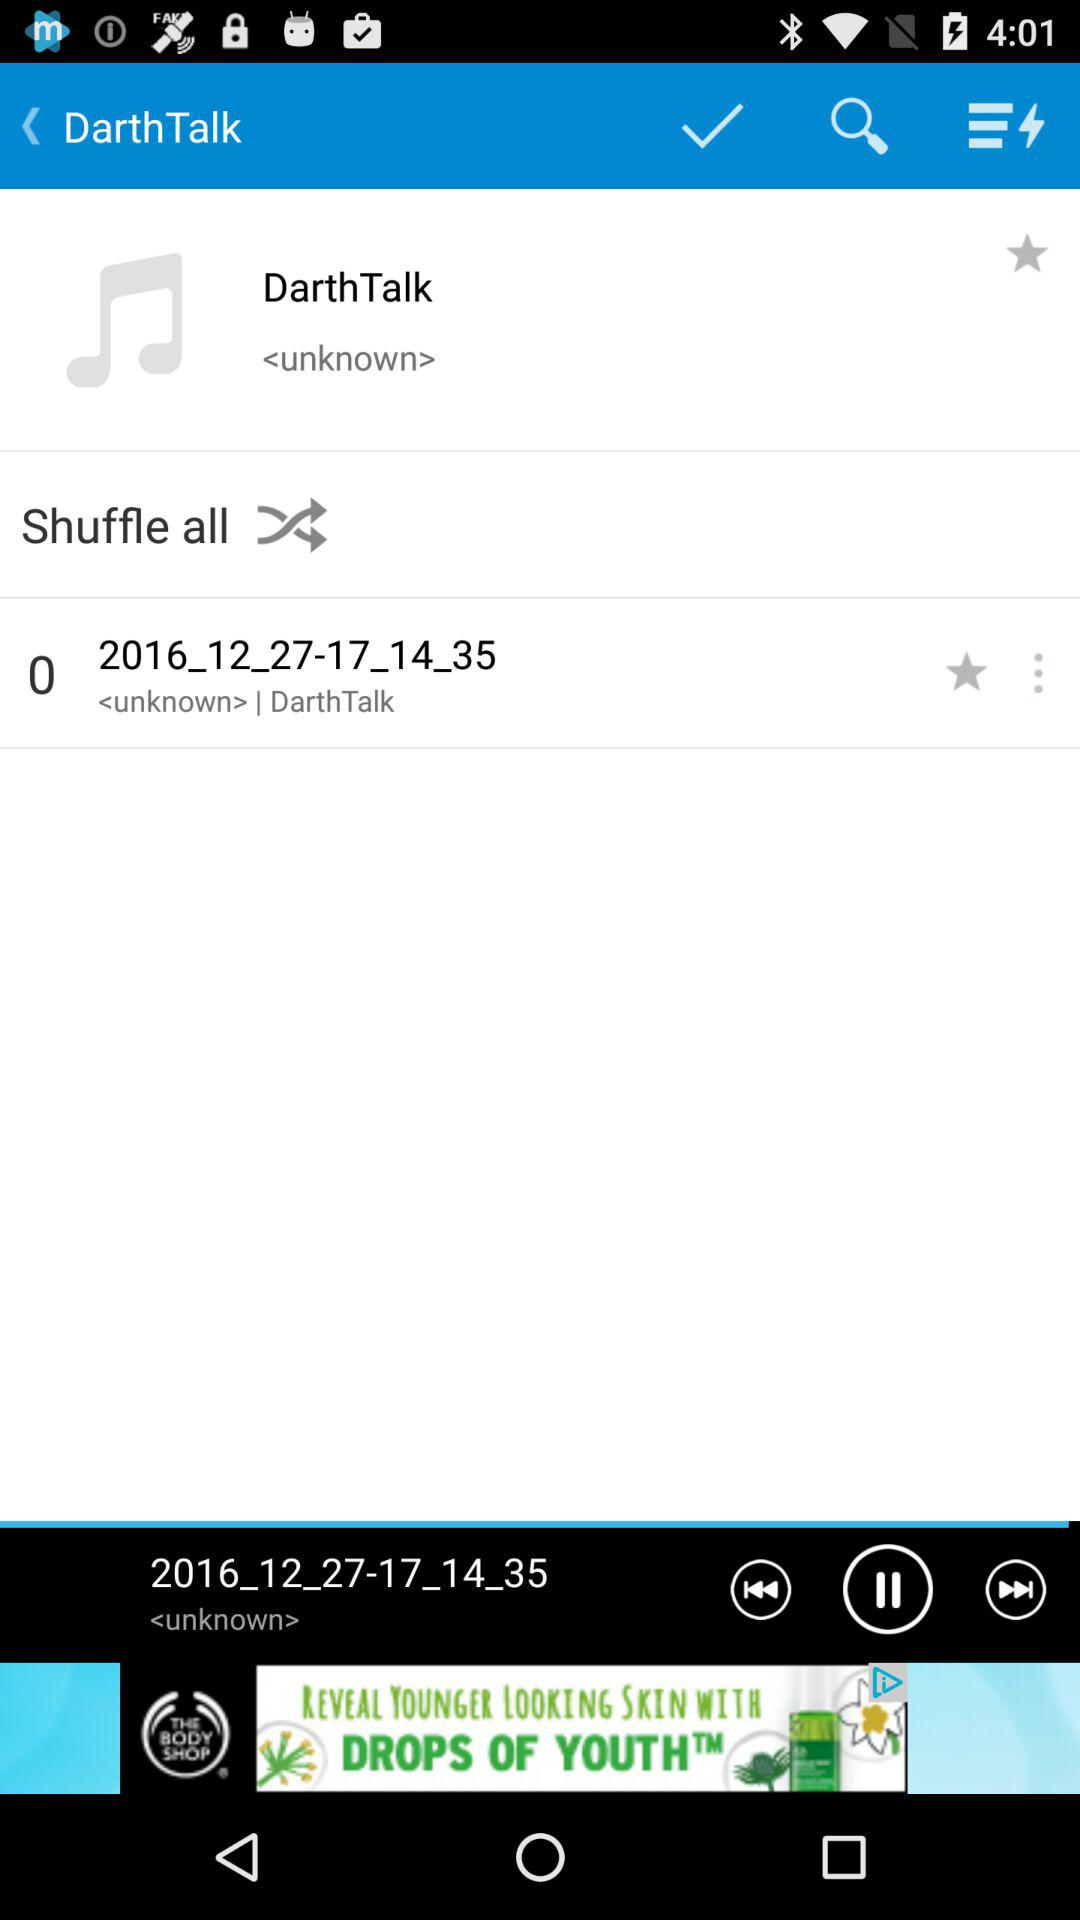Which audio is currently playing? The current audio is 2016_12_27-17_14_35. 